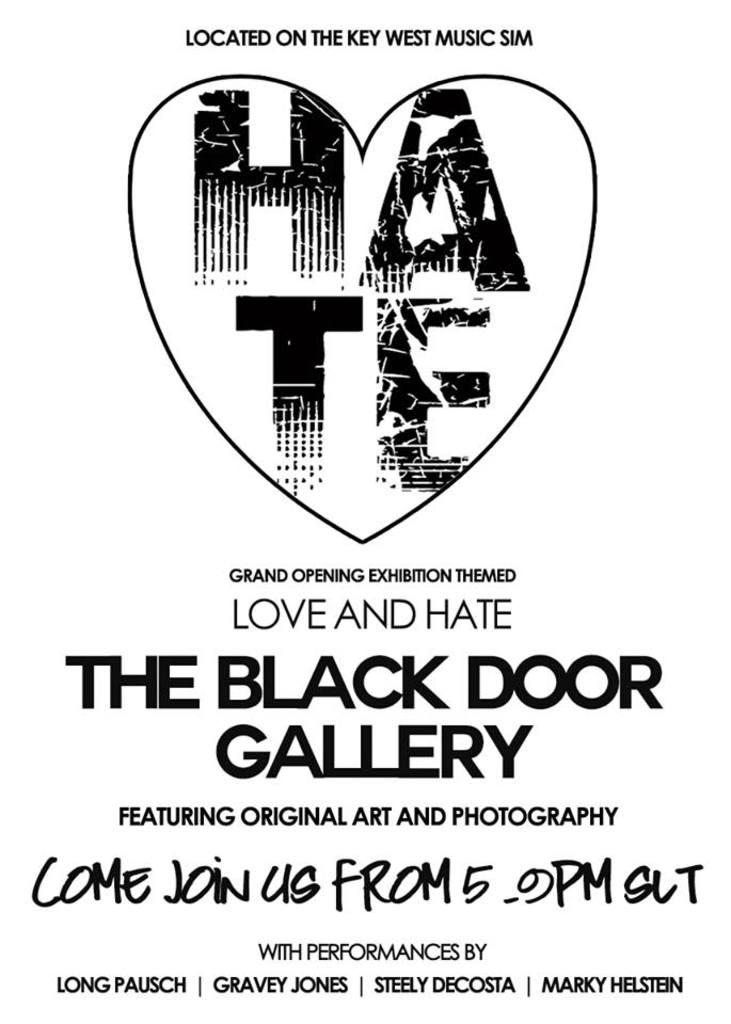Provide a one-sentence caption for the provided image. A white background poster for the exhibition The Black Door Gallery. 